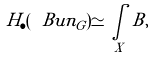Convert formula to latex. <formula><loc_0><loc_0><loc_500><loc_500>H _ { \bullet } ( \ B u n _ { G } ) \simeq \underset { X } \int \, B ,</formula> 